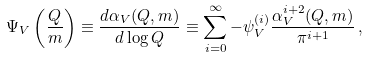<formula> <loc_0><loc_0><loc_500><loc_500>\Psi _ { V } \left ( \frac { Q } { m } \right ) \equiv \frac { d \alpha _ { V } ( Q , m ) } { d \log Q } \equiv \sum ^ { \infty } _ { i = 0 } - \psi _ { V } ^ { ( i ) } \frac { \alpha _ { V } ^ { i + 2 } ( Q , m ) } { \pi ^ { i + 1 } } \, ,</formula> 